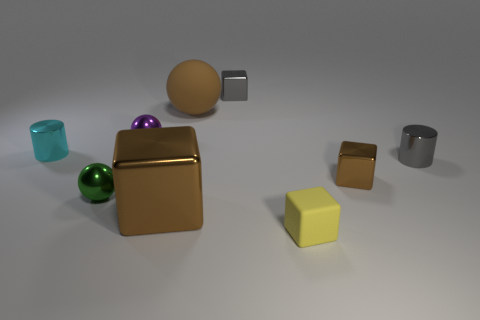Are there any tiny blue matte objects of the same shape as the small cyan object?
Your response must be concise. No. What number of other objects are the same shape as the small matte thing?
Ensure brevity in your answer.  3. What is the shape of the tiny shiny thing that is both in front of the gray cylinder and on the right side of the green object?
Your response must be concise. Cube. There is a gray thing in front of the purple metallic object; what size is it?
Give a very brief answer. Small. Does the brown ball have the same size as the gray metallic cylinder?
Make the answer very short. No. Are there fewer brown metallic things that are in front of the big metal object than gray blocks to the right of the small gray cylinder?
Provide a short and direct response. No. There is a block that is both to the left of the small matte object and in front of the cyan cylinder; what size is it?
Provide a short and direct response. Large. There is a shiny cylinder that is right of the tiny cube behind the big brown matte sphere; is there a small metal cylinder that is behind it?
Offer a very short reply. Yes. Are there any big gray matte blocks?
Offer a very short reply. No. Is the number of tiny gray objects that are behind the tiny purple ball greater than the number of big shiny things behind the gray cylinder?
Offer a very short reply. Yes. 